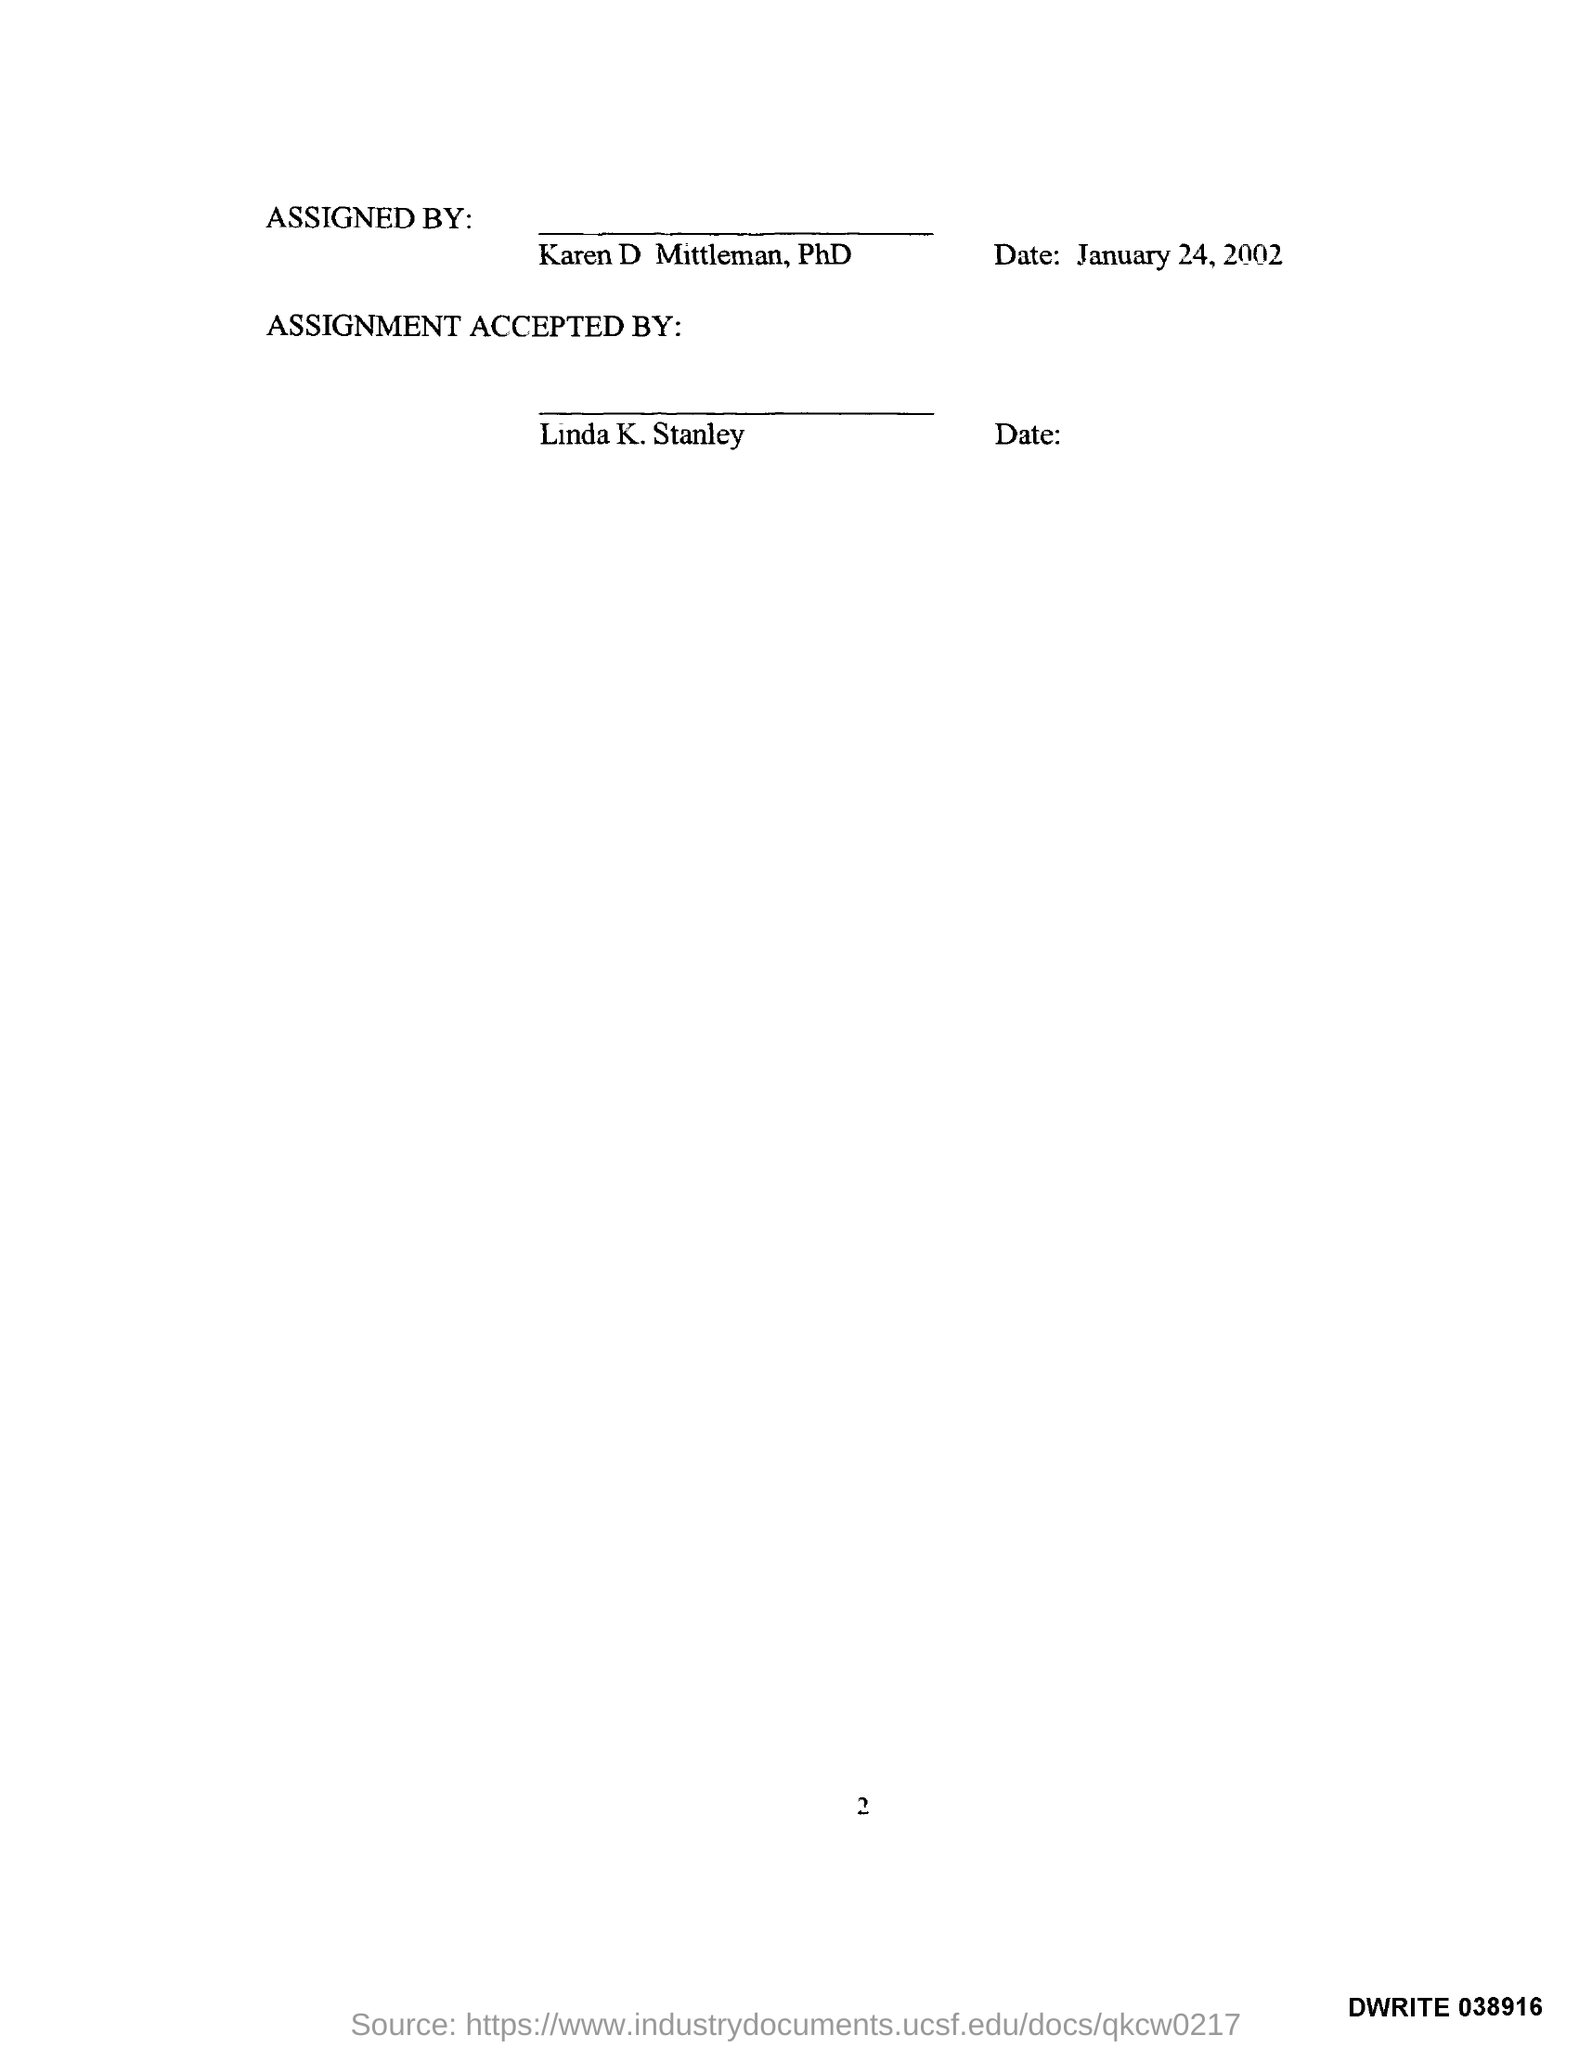Indicate a few pertinent items in this graphic. The document mentions a page number of 2. The date mentioned in this document is January 24, 2002. Linda K. Stanley has accepted the assignment. The document has been assigned by Karen D. Mittleman, PhD. 